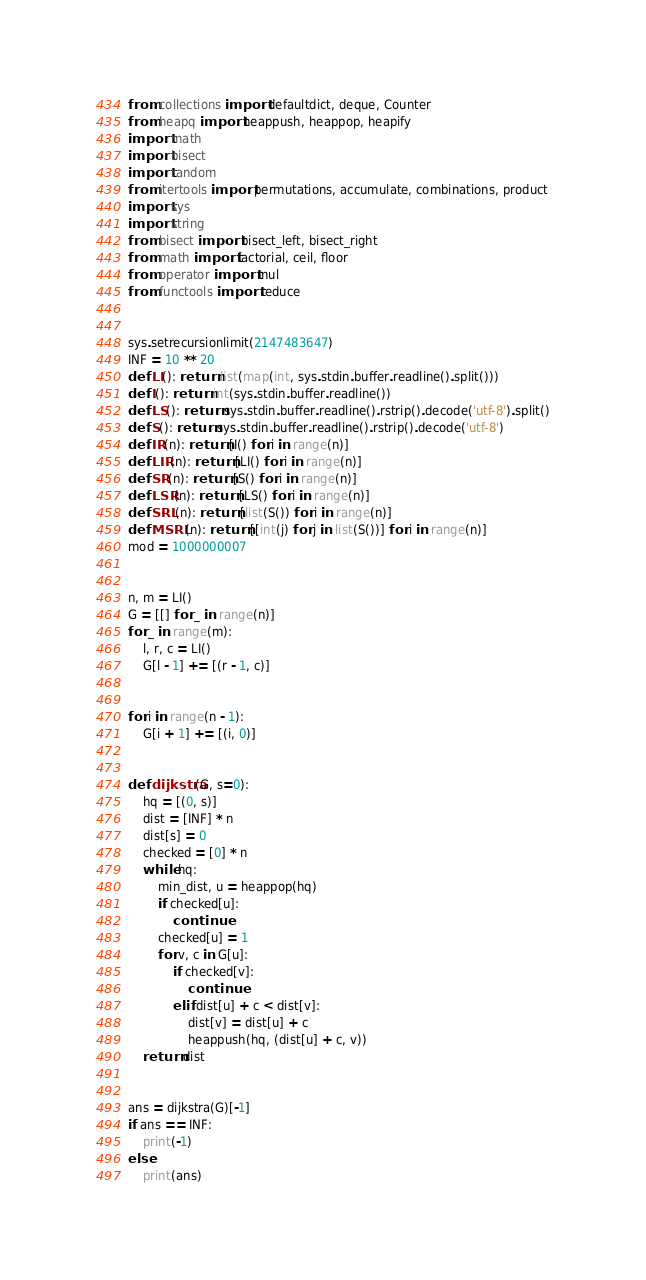Convert code to text. <code><loc_0><loc_0><loc_500><loc_500><_Python_>from collections import defaultdict, deque, Counter
from heapq import heappush, heappop, heapify
import math
import bisect
import random
from itertools import permutations, accumulate, combinations, product
import sys
import string
from bisect import bisect_left, bisect_right
from math import factorial, ceil, floor
from operator import mul
from functools import reduce


sys.setrecursionlimit(2147483647)
INF = 10 ** 20
def LI(): return list(map(int, sys.stdin.buffer.readline().split()))
def I(): return int(sys.stdin.buffer.readline())
def LS(): return sys.stdin.buffer.readline().rstrip().decode('utf-8').split()
def S(): return sys.stdin.buffer.readline().rstrip().decode('utf-8')
def IR(n): return [I() for i in range(n)]
def LIR(n): return [LI() for i in range(n)]
def SR(n): return [S() for i in range(n)]
def LSR(n): return [LS() for i in range(n)]
def SRL(n): return [list(S()) for i in range(n)]
def MSRL(n): return [[int(j) for j in list(S())] for i in range(n)]
mod = 1000000007


n, m = LI()
G = [[] for _ in range(n)]
for _ in range(m):
    l, r, c = LI()
    G[l - 1] += [(r - 1, c)]


for i in range(n - 1):
    G[i + 1] += [(i, 0)]


def dijkstra(G, s=0):
    hq = [(0, s)]
    dist = [INF] * n
    dist[s] = 0
    checked = [0] * n
    while hq:
        min_dist, u = heappop(hq)
        if checked[u]:
            continue
        checked[u] = 1
        for v, c in G[u]:
            if checked[v]:
                continue
            elif dist[u] + c < dist[v]:
                dist[v] = dist[u] + c
                heappush(hq, (dist[u] + c, v))
    return dist


ans = dijkstra(G)[-1]
if ans == INF:
    print(-1)
else:
    print(ans)
</code> 